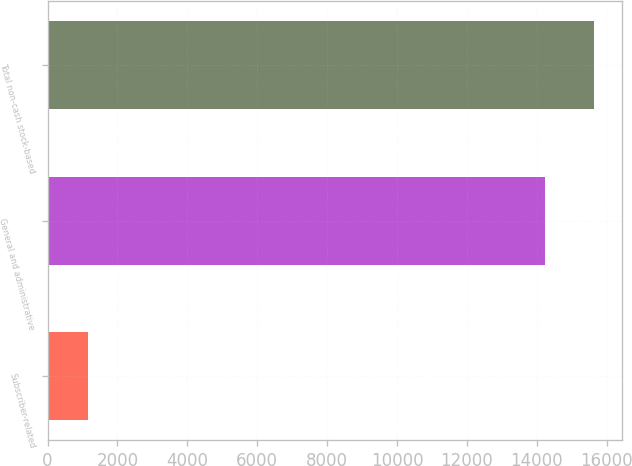Convert chart to OTSL. <chart><loc_0><loc_0><loc_500><loc_500><bar_chart><fcel>Subscriber-related<fcel>General and administrative<fcel>Total non-cash stock-based<nl><fcel>1160<fcel>14227<fcel>15649.7<nl></chart> 